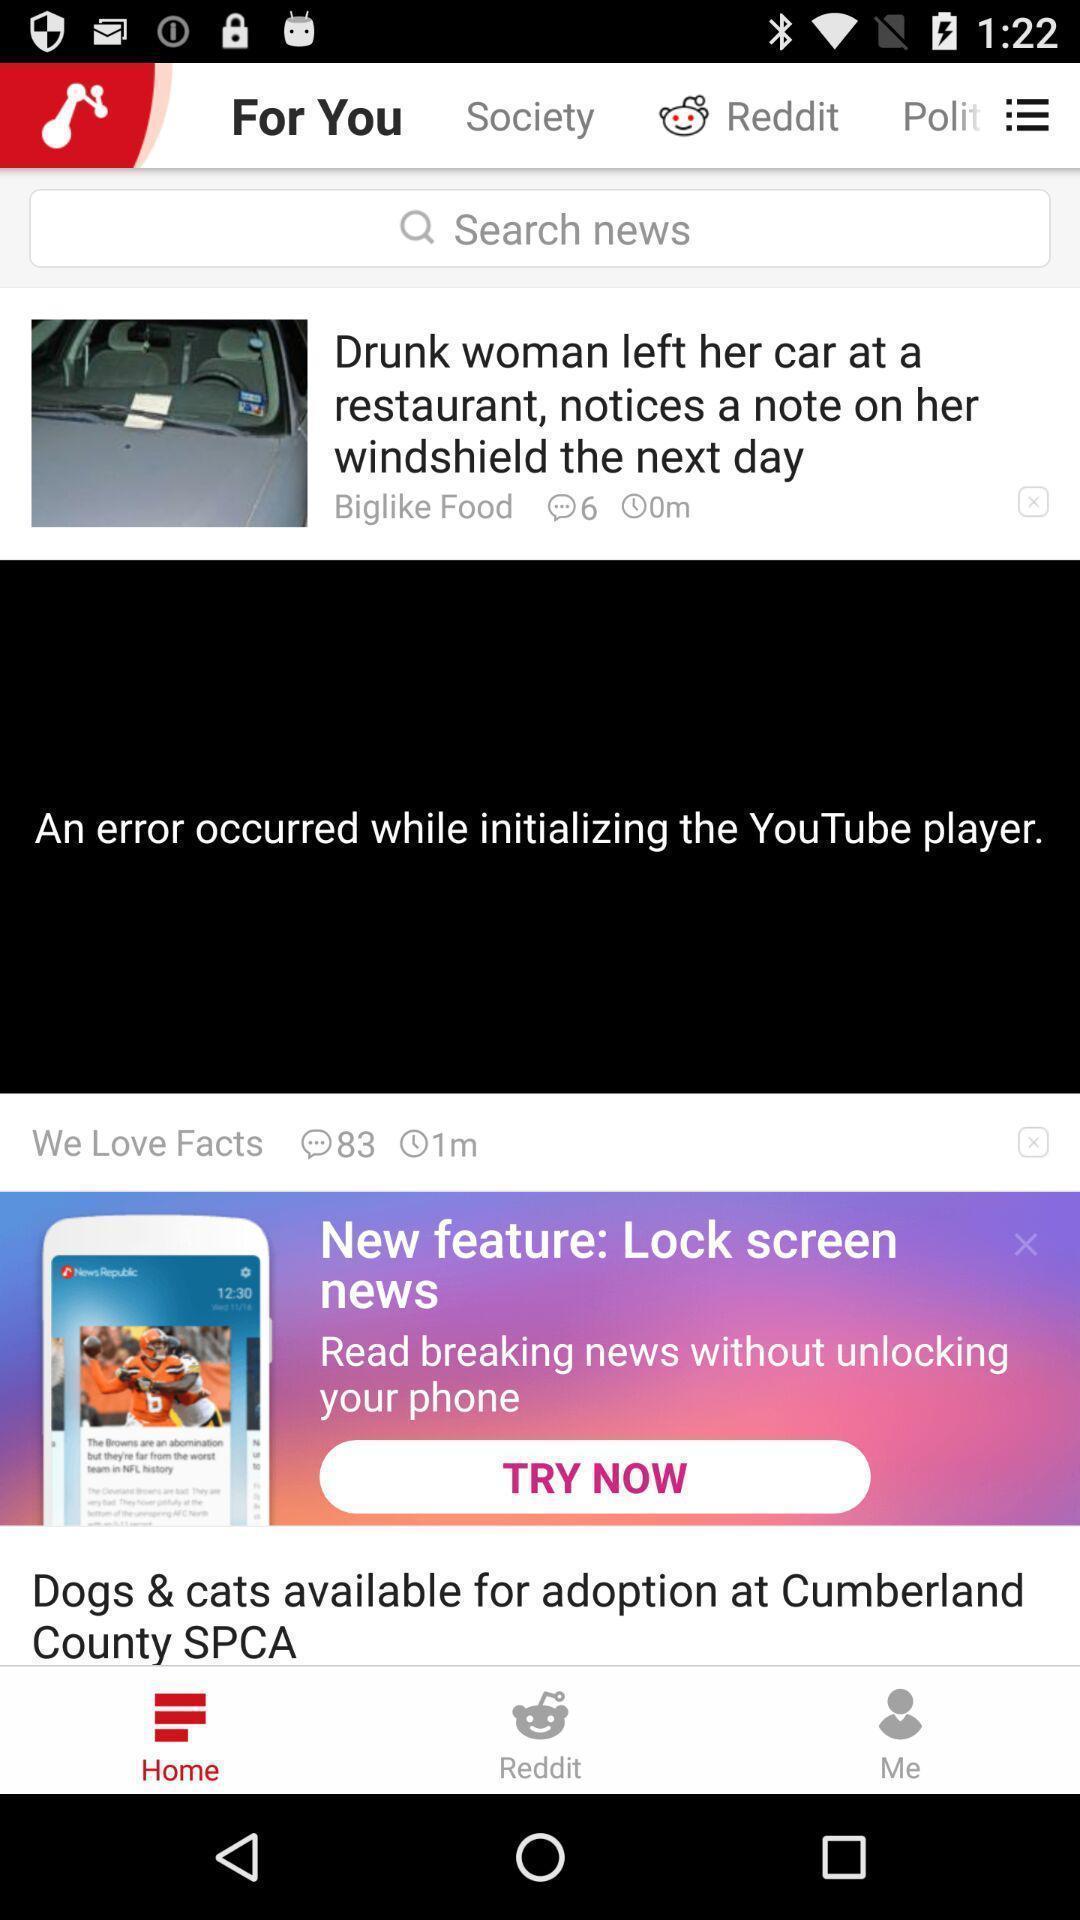Give me a summary of this screen capture. Page of a social news app. 